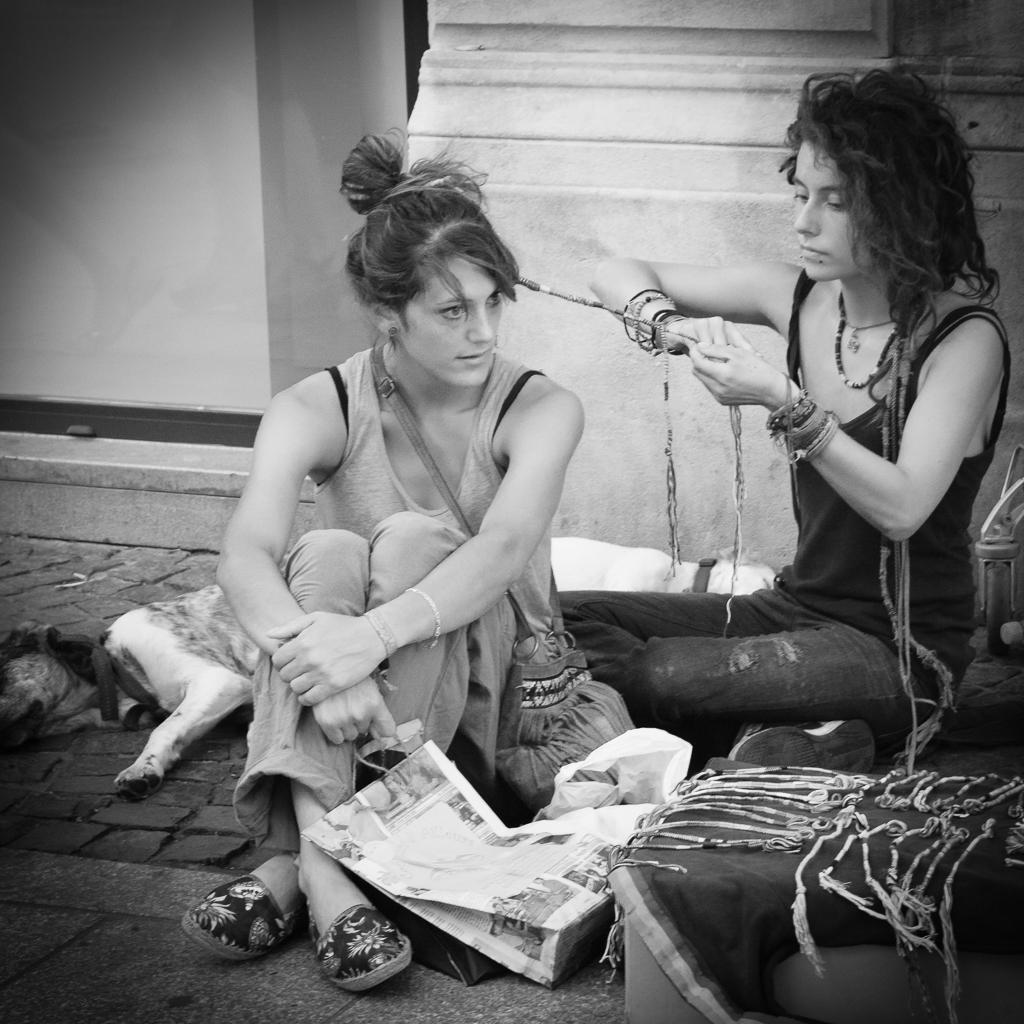What are the two people in the image doing? The two people are sitting on the floor. What can be seen near the people? There is a bag in the image. What type of animals are present in the image? There are dogs in the image. Can you describe any other objects in the image? There are some objects in the image. What is visible in the background of the image? There is a wall in the background of the image. What type of straw is being used as a punishment in the image? There is no straw or punishment present in the image. Where is the mailbox located in the image? There is no mailbox present in the image. 